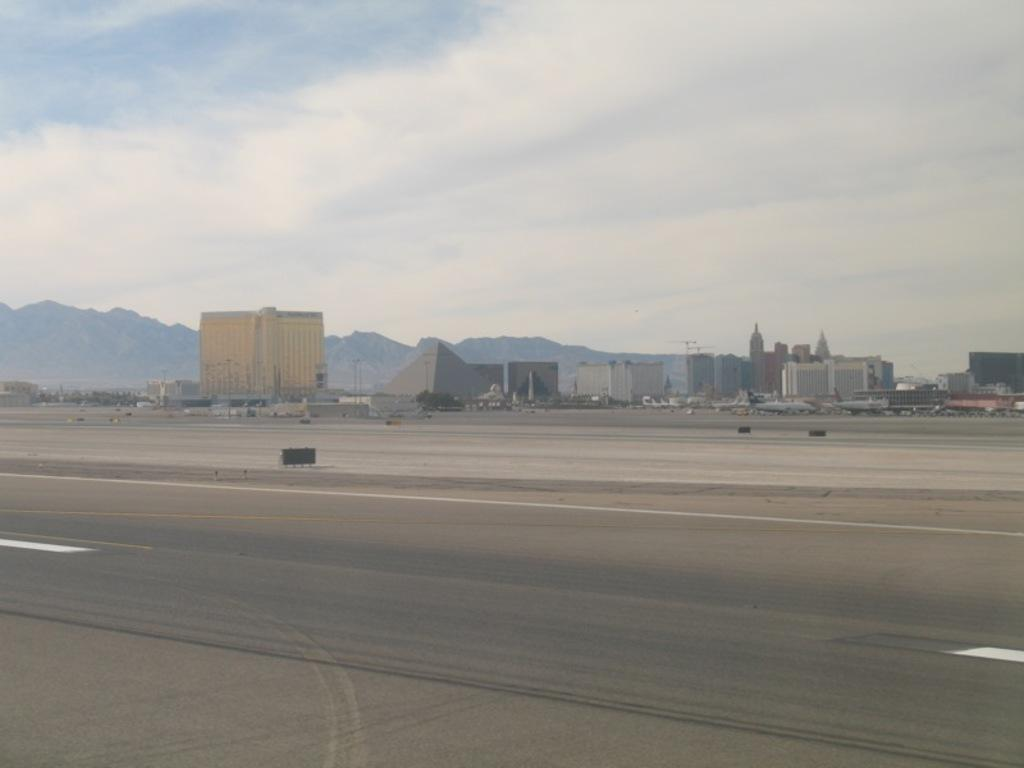What type of pathway is present in the image? There is a road in the image. What structures can be seen in the image? There are buildings and a pyramid-like structure visible in the image. What type of natural formation is present in the image? There are mountains in the image. What mode of transportation can be seen in the image? There are airplanes on a runway in the image. What part of the environment is visible in the image? The sky is visible in the image. What type of waste is present on the runway in the image? There is no waste present on the runway in the image. What type of oil can be seen dripping from the pyramid-like structure in the image? There is no oil present, nor is there any dripping substance from the pyramid-like structure in the image. 